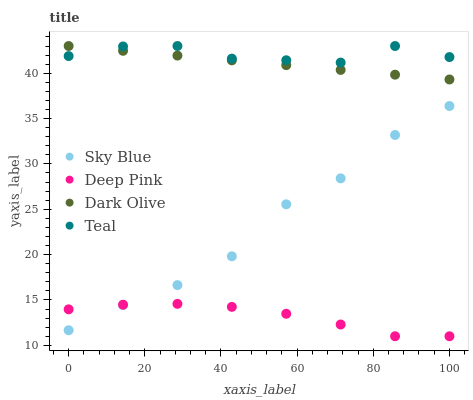Does Deep Pink have the minimum area under the curve?
Answer yes or no. Yes. Does Teal have the maximum area under the curve?
Answer yes or no. Yes. Does Sky Blue have the minimum area under the curve?
Answer yes or no. No. Does Sky Blue have the maximum area under the curve?
Answer yes or no. No. Is Dark Olive the smoothest?
Answer yes or no. Yes. Is Sky Blue the roughest?
Answer yes or no. Yes. Is Deep Pink the smoothest?
Answer yes or no. No. Is Deep Pink the roughest?
Answer yes or no. No. Does Deep Pink have the lowest value?
Answer yes or no. Yes. Does Sky Blue have the lowest value?
Answer yes or no. No. Does Teal have the highest value?
Answer yes or no. Yes. Does Sky Blue have the highest value?
Answer yes or no. No. Is Deep Pink less than Dark Olive?
Answer yes or no. Yes. Is Dark Olive greater than Sky Blue?
Answer yes or no. Yes. Does Dark Olive intersect Teal?
Answer yes or no. Yes. Is Dark Olive less than Teal?
Answer yes or no. No. Is Dark Olive greater than Teal?
Answer yes or no. No. Does Deep Pink intersect Dark Olive?
Answer yes or no. No. 